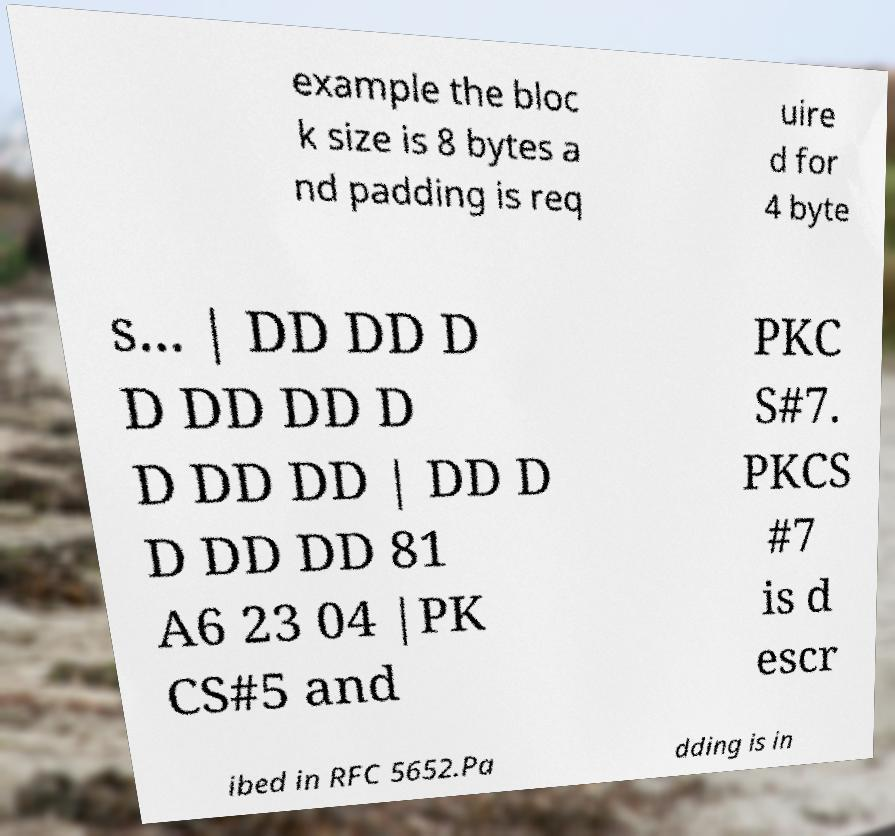There's text embedded in this image that I need extracted. Can you transcribe it verbatim? example the bloc k size is 8 bytes a nd padding is req uire d for 4 byte s... | DD DD D D DD DD D D DD DD | DD D D DD DD 81 A6 23 04 |PK CS#5 and PKC S#7. PKCS #7 is d escr ibed in RFC 5652.Pa dding is in 